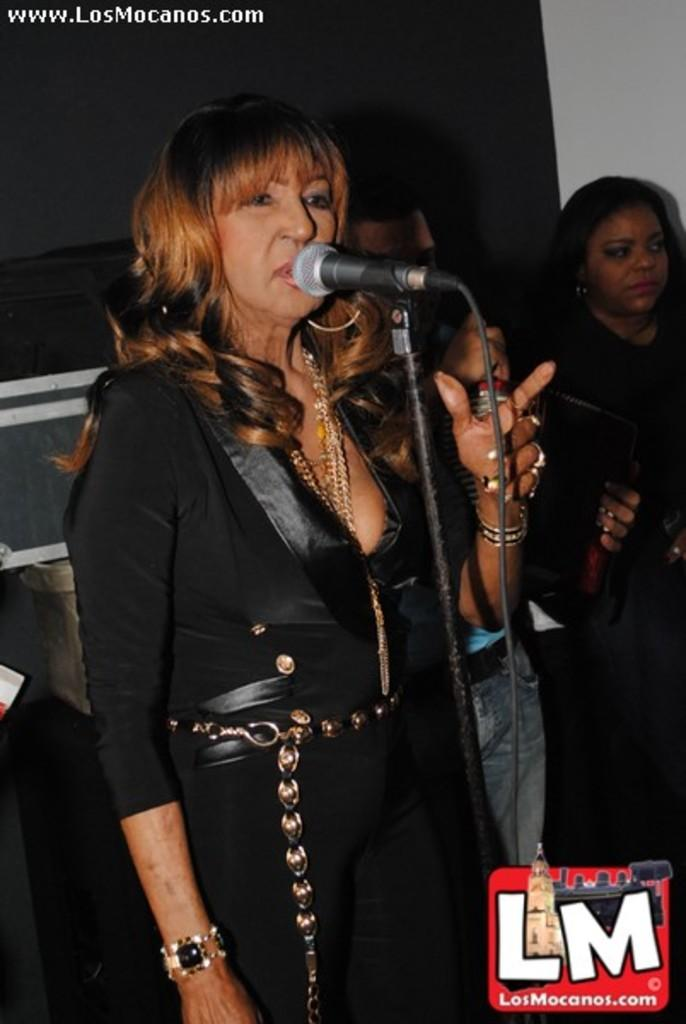What are the people in the image wearing? The persons in the image are wearing clothes. What is the person in front of the mic doing? The person is standing in front of a mic, which suggests they might be singing or speaking. Can you describe the logo in the image? The logo is located in the bottom right of the image. Can you tell me how many bubbles are floating around the person standing in front of the mic? There are no bubbles present in the image; it features persons wearing clothes and a person standing in front of a mic. 